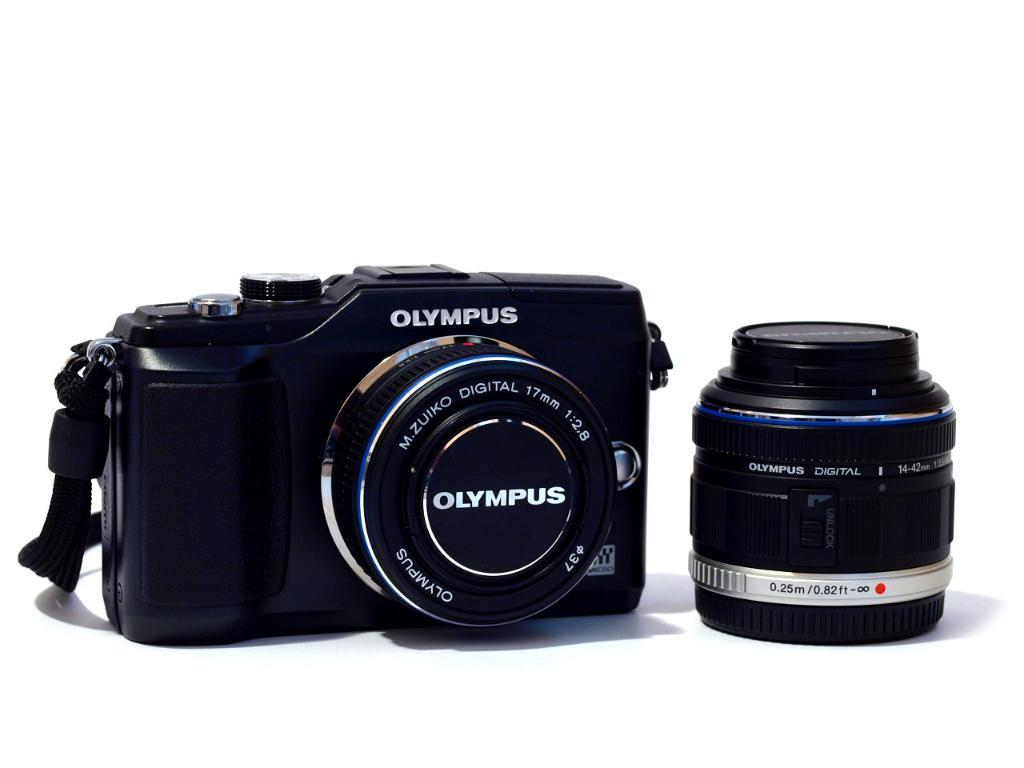<image>
Present a compact description of the photo's key features. A black Olympus digital camera and zoom lens. 